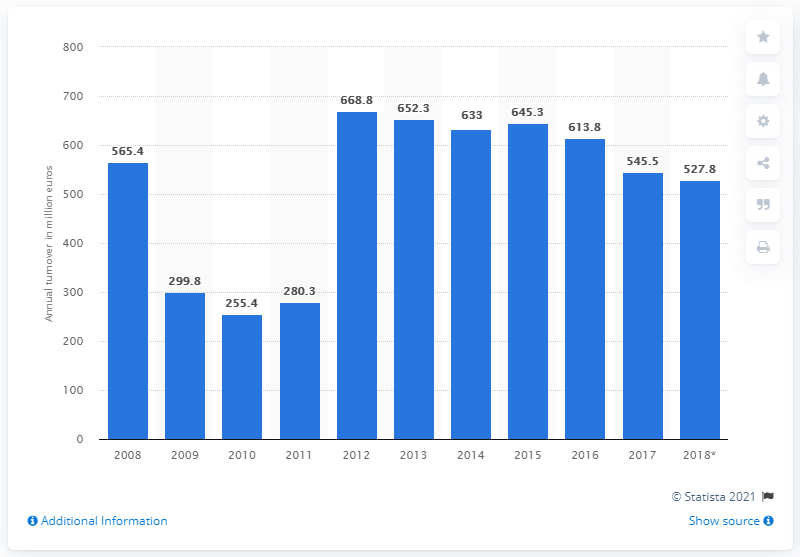Give some essential details in this illustration. In 2018, the total turnover of food, beverage, and tobacco stores in Croatia was 527.8 million euros. 